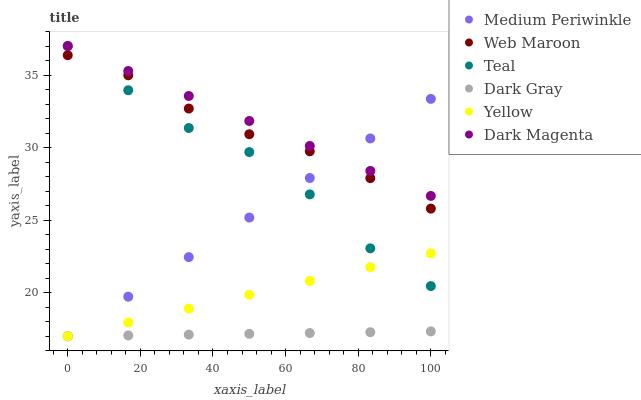Does Dark Gray have the minimum area under the curve?
Answer yes or no. Yes. Does Dark Magenta have the maximum area under the curve?
Answer yes or no. Yes. Does Medium Periwinkle have the minimum area under the curve?
Answer yes or no. No. Does Medium Periwinkle have the maximum area under the curve?
Answer yes or no. No. Is Yellow the smoothest?
Answer yes or no. Yes. Is Teal the roughest?
Answer yes or no. Yes. Is Medium Periwinkle the smoothest?
Answer yes or no. No. Is Medium Periwinkle the roughest?
Answer yes or no. No. Does Medium Periwinkle have the lowest value?
Answer yes or no. Yes. Does Web Maroon have the lowest value?
Answer yes or no. No. Does Teal have the highest value?
Answer yes or no. Yes. Does Medium Periwinkle have the highest value?
Answer yes or no. No. Is Dark Gray less than Web Maroon?
Answer yes or no. Yes. Is Dark Magenta greater than Yellow?
Answer yes or no. Yes. Does Medium Periwinkle intersect Dark Gray?
Answer yes or no. Yes. Is Medium Periwinkle less than Dark Gray?
Answer yes or no. No. Is Medium Periwinkle greater than Dark Gray?
Answer yes or no. No. Does Dark Gray intersect Web Maroon?
Answer yes or no. No. 